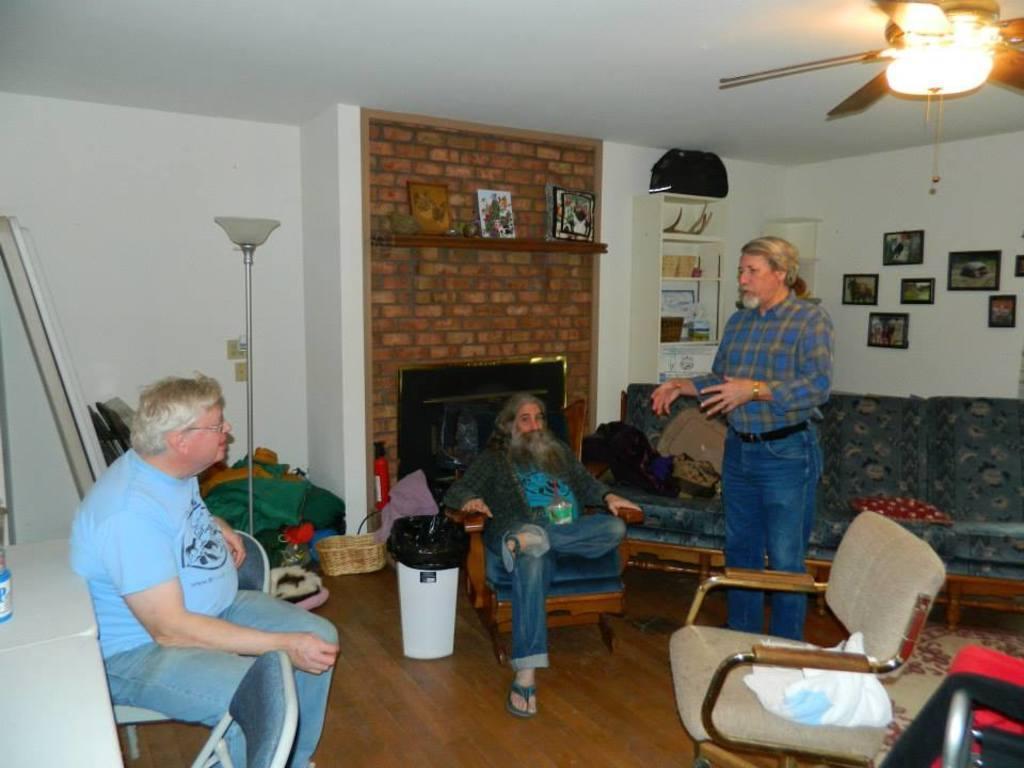Please provide a concise description of this image. It is a closed room where the picture is taken and in the middle one man is sitting on the chair and beside him there is one basket one bin and behind him there is one fire place and brick wall on which there are some photos are kept and corner there is one shelf and things are kept in it and at the corner of the picture one person is standing in blue dress and behind him there is one sofa and there is a wall with photos covered on it and there is a fan in the room and at the left corner of the picture one person is sitting and behind him there are some things kept at the corner and there is one table and chair. 